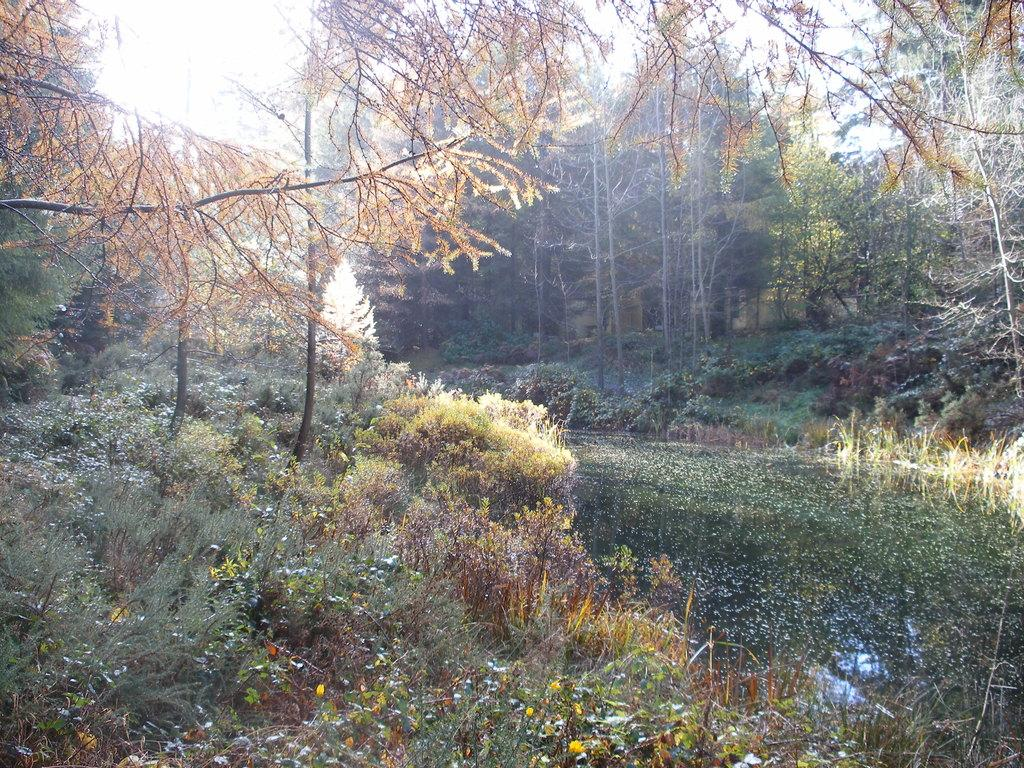What type of plants can be seen in the image? There are plants with flowers in the image. What else is visible in the image besides the plants? There is water and trees visible in the image. What can be seen in the background of the image? The sky is visible in the background of the image. How much wealth is displayed in the image? There is no indication of wealth in the image, as it features plants, water, trees, and the sky. What type of alley can be seen in the image? There is no alley present in the image. 